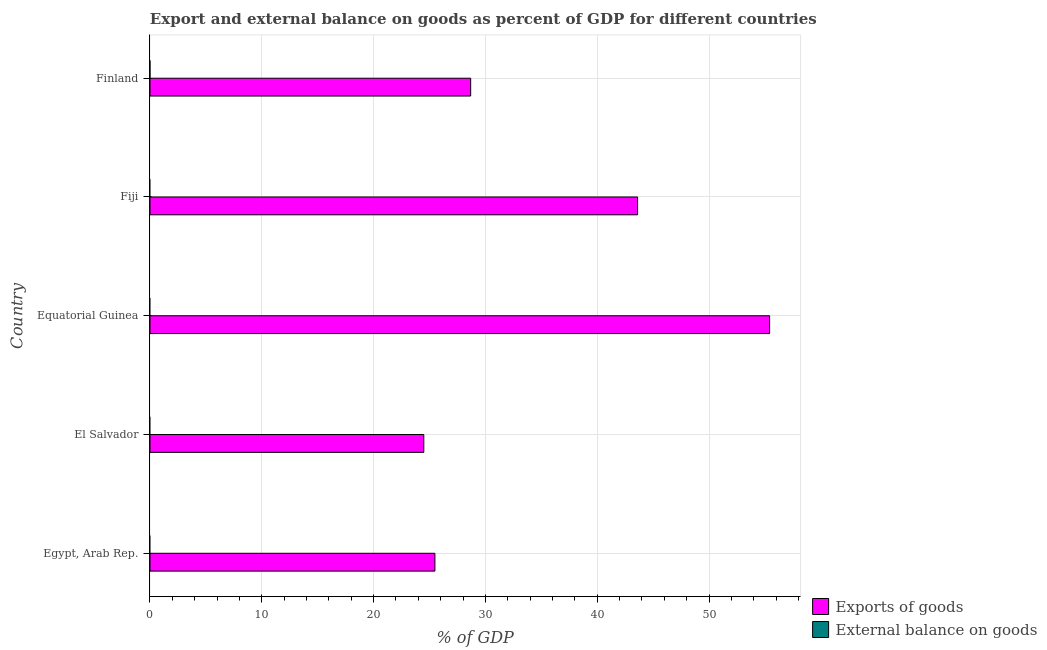What is the label of the 4th group of bars from the top?
Your answer should be very brief. El Salvador. In how many cases, is the number of bars for a given country not equal to the number of legend labels?
Make the answer very short. 5. Across all countries, what is the maximum export of goods as percentage of gdp?
Give a very brief answer. 55.42. Across all countries, what is the minimum export of goods as percentage of gdp?
Your response must be concise. 24.49. In which country was the export of goods as percentage of gdp maximum?
Make the answer very short. Equatorial Guinea. What is the difference between the export of goods as percentage of gdp in Egypt, Arab Rep. and that in Fiji?
Keep it short and to the point. -18.13. What is the difference between the export of goods as percentage of gdp in Fiji and the external balance on goods as percentage of gdp in Finland?
Keep it short and to the point. 43.61. What is the ratio of the export of goods as percentage of gdp in Egypt, Arab Rep. to that in Equatorial Guinea?
Provide a succinct answer. 0.46. What is the difference between the highest and the second highest export of goods as percentage of gdp?
Your answer should be very brief. 11.81. What is the difference between the highest and the lowest export of goods as percentage of gdp?
Ensure brevity in your answer.  30.93. In how many countries, is the export of goods as percentage of gdp greater than the average export of goods as percentage of gdp taken over all countries?
Offer a very short reply. 2. Is the sum of the export of goods as percentage of gdp in El Salvador and Equatorial Guinea greater than the maximum external balance on goods as percentage of gdp across all countries?
Offer a very short reply. Yes. How many countries are there in the graph?
Provide a succinct answer. 5. Does the graph contain any zero values?
Your answer should be very brief. Yes. What is the title of the graph?
Offer a terse response. Export and external balance on goods as percent of GDP for different countries. Does "Commercial service imports" appear as one of the legend labels in the graph?
Ensure brevity in your answer.  No. What is the label or title of the X-axis?
Ensure brevity in your answer.  % of GDP. What is the % of GDP of Exports of goods in Egypt, Arab Rep.?
Offer a very short reply. 25.48. What is the % of GDP of Exports of goods in El Salvador?
Keep it short and to the point. 24.49. What is the % of GDP of Exports of goods in Equatorial Guinea?
Offer a terse response. 55.42. What is the % of GDP of External balance on goods in Equatorial Guinea?
Provide a short and direct response. 0. What is the % of GDP of Exports of goods in Fiji?
Offer a terse response. 43.61. What is the % of GDP of Exports of goods in Finland?
Make the answer very short. 28.68. What is the % of GDP of External balance on goods in Finland?
Give a very brief answer. 0. Across all countries, what is the maximum % of GDP of Exports of goods?
Provide a succinct answer. 55.42. Across all countries, what is the minimum % of GDP of Exports of goods?
Keep it short and to the point. 24.49. What is the total % of GDP of Exports of goods in the graph?
Ensure brevity in your answer.  177.68. What is the total % of GDP in External balance on goods in the graph?
Provide a short and direct response. 0. What is the difference between the % of GDP of Exports of goods in Egypt, Arab Rep. and that in Equatorial Guinea?
Your response must be concise. -29.94. What is the difference between the % of GDP of Exports of goods in Egypt, Arab Rep. and that in Fiji?
Your answer should be compact. -18.13. What is the difference between the % of GDP of Exports of goods in Egypt, Arab Rep. and that in Finland?
Give a very brief answer. -3.2. What is the difference between the % of GDP in Exports of goods in El Salvador and that in Equatorial Guinea?
Provide a short and direct response. -30.93. What is the difference between the % of GDP in Exports of goods in El Salvador and that in Fiji?
Provide a succinct answer. -19.12. What is the difference between the % of GDP of Exports of goods in El Salvador and that in Finland?
Your answer should be very brief. -4.19. What is the difference between the % of GDP in Exports of goods in Equatorial Guinea and that in Fiji?
Offer a very short reply. 11.81. What is the difference between the % of GDP of Exports of goods in Equatorial Guinea and that in Finland?
Provide a short and direct response. 26.74. What is the difference between the % of GDP in Exports of goods in Fiji and that in Finland?
Provide a short and direct response. 14.93. What is the average % of GDP of Exports of goods per country?
Keep it short and to the point. 35.54. What is the average % of GDP of External balance on goods per country?
Your answer should be very brief. 0. What is the ratio of the % of GDP in Exports of goods in Egypt, Arab Rep. to that in El Salvador?
Offer a very short reply. 1.04. What is the ratio of the % of GDP of Exports of goods in Egypt, Arab Rep. to that in Equatorial Guinea?
Provide a short and direct response. 0.46. What is the ratio of the % of GDP of Exports of goods in Egypt, Arab Rep. to that in Fiji?
Offer a very short reply. 0.58. What is the ratio of the % of GDP in Exports of goods in Egypt, Arab Rep. to that in Finland?
Ensure brevity in your answer.  0.89. What is the ratio of the % of GDP in Exports of goods in El Salvador to that in Equatorial Guinea?
Your answer should be very brief. 0.44. What is the ratio of the % of GDP in Exports of goods in El Salvador to that in Fiji?
Your answer should be compact. 0.56. What is the ratio of the % of GDP in Exports of goods in El Salvador to that in Finland?
Provide a short and direct response. 0.85. What is the ratio of the % of GDP of Exports of goods in Equatorial Guinea to that in Fiji?
Offer a terse response. 1.27. What is the ratio of the % of GDP of Exports of goods in Equatorial Guinea to that in Finland?
Your answer should be compact. 1.93. What is the ratio of the % of GDP in Exports of goods in Fiji to that in Finland?
Your answer should be very brief. 1.52. What is the difference between the highest and the second highest % of GDP of Exports of goods?
Your answer should be very brief. 11.81. What is the difference between the highest and the lowest % of GDP of Exports of goods?
Offer a terse response. 30.93. 